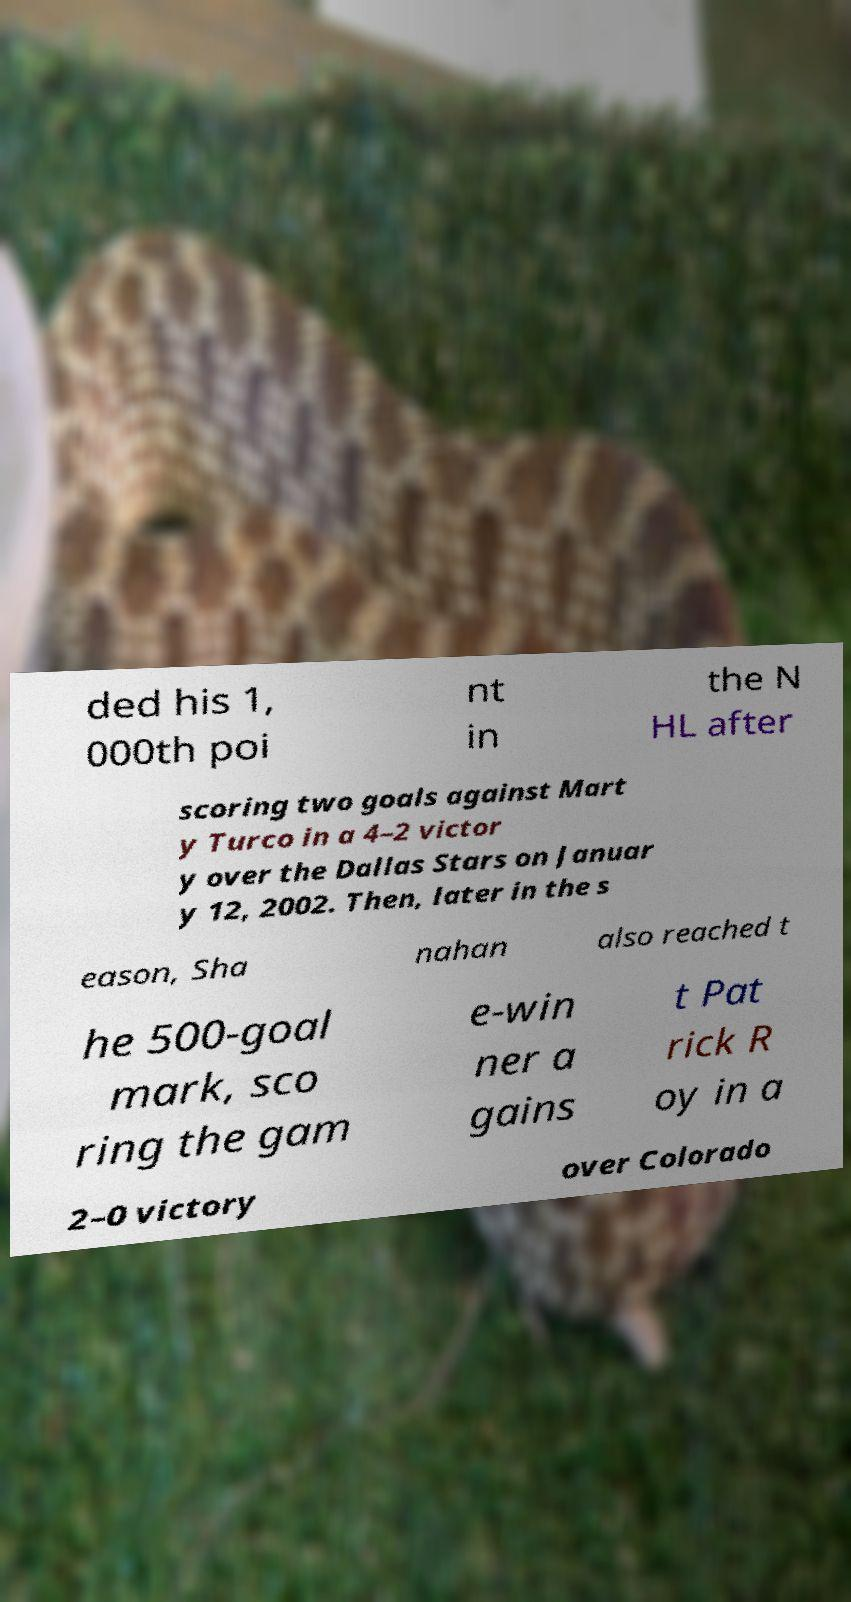There's text embedded in this image that I need extracted. Can you transcribe it verbatim? ded his 1, 000th poi nt in the N HL after scoring two goals against Mart y Turco in a 4–2 victor y over the Dallas Stars on Januar y 12, 2002. Then, later in the s eason, Sha nahan also reached t he 500-goal mark, sco ring the gam e-win ner a gains t Pat rick R oy in a 2–0 victory over Colorado 